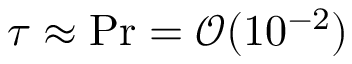Convert formula to latex. <formula><loc_0><loc_0><loc_500><loc_500>\tau \approx P r = \mathcal { O } ( 1 0 ^ { - 2 } )</formula> 